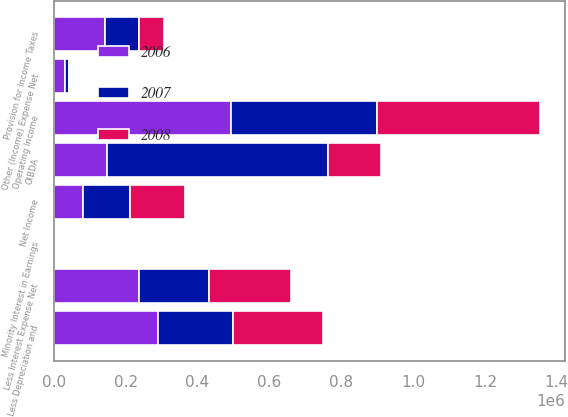<chart> <loc_0><loc_0><loc_500><loc_500><stacked_bar_chart><ecel><fcel>OIBDA<fcel>Less Depreciation and<fcel>Operating Income<fcel>Less Interest Expense Net<fcel>Other (Income) Expense Net<fcel>Provision for Income Taxes<fcel>Minority Interest in Earnings<fcel>Net Income<nl><fcel>2007<fcel>615560<fcel>208373<fcel>407187<fcel>194958<fcel>11989<fcel>93795<fcel>1560<fcel>128863<nl><fcel>2008<fcel>148009<fcel>249294<fcel>454718<fcel>228593<fcel>3101<fcel>69010<fcel>920<fcel>153094<nl><fcel>2006<fcel>148009<fcel>290738<fcel>492530<fcel>236635<fcel>31028<fcel>142924<fcel>94<fcel>82037<nl></chart> 